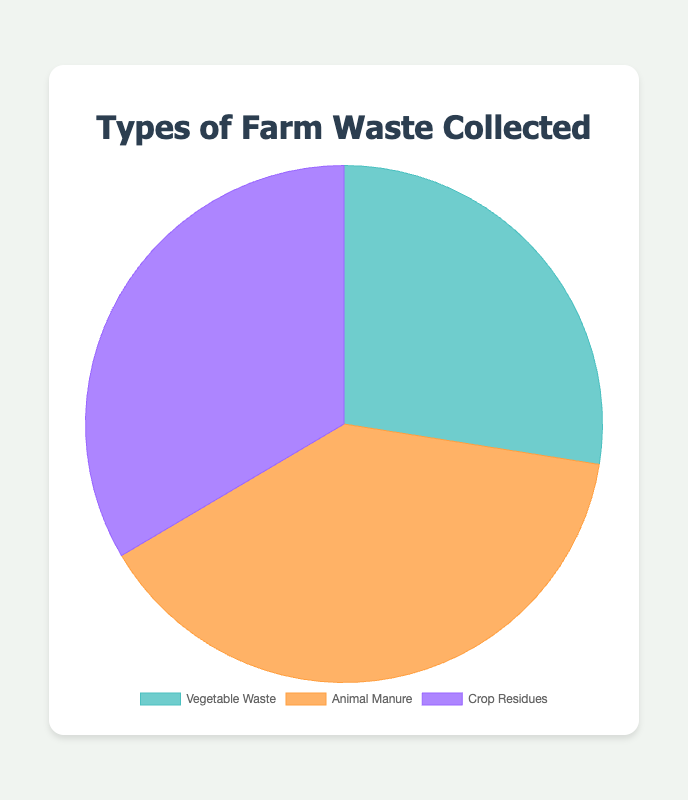How many total kilograms of farm waste were collected? Sum all the values: 5500 kg (Vegetable Waste) + 7800 kg (Animal Manure) + 6700 kg (Crop Residues). 5500 + 7800 + 6700 = 20000 kg
Answer: 20000 kg Which type of farm waste was collected the most? Compare the amounts: Vegetable Waste (5500 kg), Animal Manure (7800 kg), and Crop Residues (6700 kg). Animal Manure has the highest amount (7800 kg).
Answer: Animal Manure What is the percentage of Crop Residues in the total waste collected? Calculate the percentage: (Crop Residues / Total Waste) * 100 = (6700 / 20000) * 100 = 33.5%
Answer: 33.5% Which type of farm waste has the second-largest quantity collected? Compare the amounts: Vegetable Waste (5500 kg), Animal Manure (7800 kg), and Crop Residues (6700 kg). The second-largest amount is Crop Residues (6700 kg).
Answer: Crop Residues What is the difference between the amounts of Animal Manure and Vegetable Waste? Subtract the amount of Vegetable Waste from Animal Manure: 7800 kg - 5500 kg = 2300 kg
Answer: 2300 kg What is the average amount of waste collected per type? Calculate the average: Total Waste / Number of Types = 20000 kg / 3 = 6666.67 kg
Answer: 6666.67 kg What is the ratio of Vegetable Waste to Animal Manure? Divide the amount of Vegetable Waste by the amount of Animal Manure: 5500 kg / 7800 kg = 0.7051 ≈ 0.71
Answer: 0.71 If 'Crop Residues' is represented by purple, what colors represent 'Vegetable Waste' and 'Animal Manure'? Based on the pie chart colors: Vegetable Waste is represented by green, and Animal Manure is represented by orange.
Answer: Green and Orange Which two types of waste combined amount to more than half of the total collected waste? Calculate combinations: 5500 kg (Vegetable Waste) + 7800 kg (Animal Manure) = 13300 kg, and 7800 kg (Animal Manure) + 6700 kg (Crop Residues) = 14500 kg. Both are more than half of 20000 kg (~10000 kg).
Answer: Animal Manure and (either Vegetable Waste or Crop Residues) What's the combined percentage of Vegetable Waste and Animal Manure in the total waste? Sum the amounts: 5500 kg (Vegetable Waste) + 7800 kg (Animal Manure) = 13300 kg. Calculate the percentage: (13300 / 20000) * 100 = 66.5%
Answer: 66.5% 